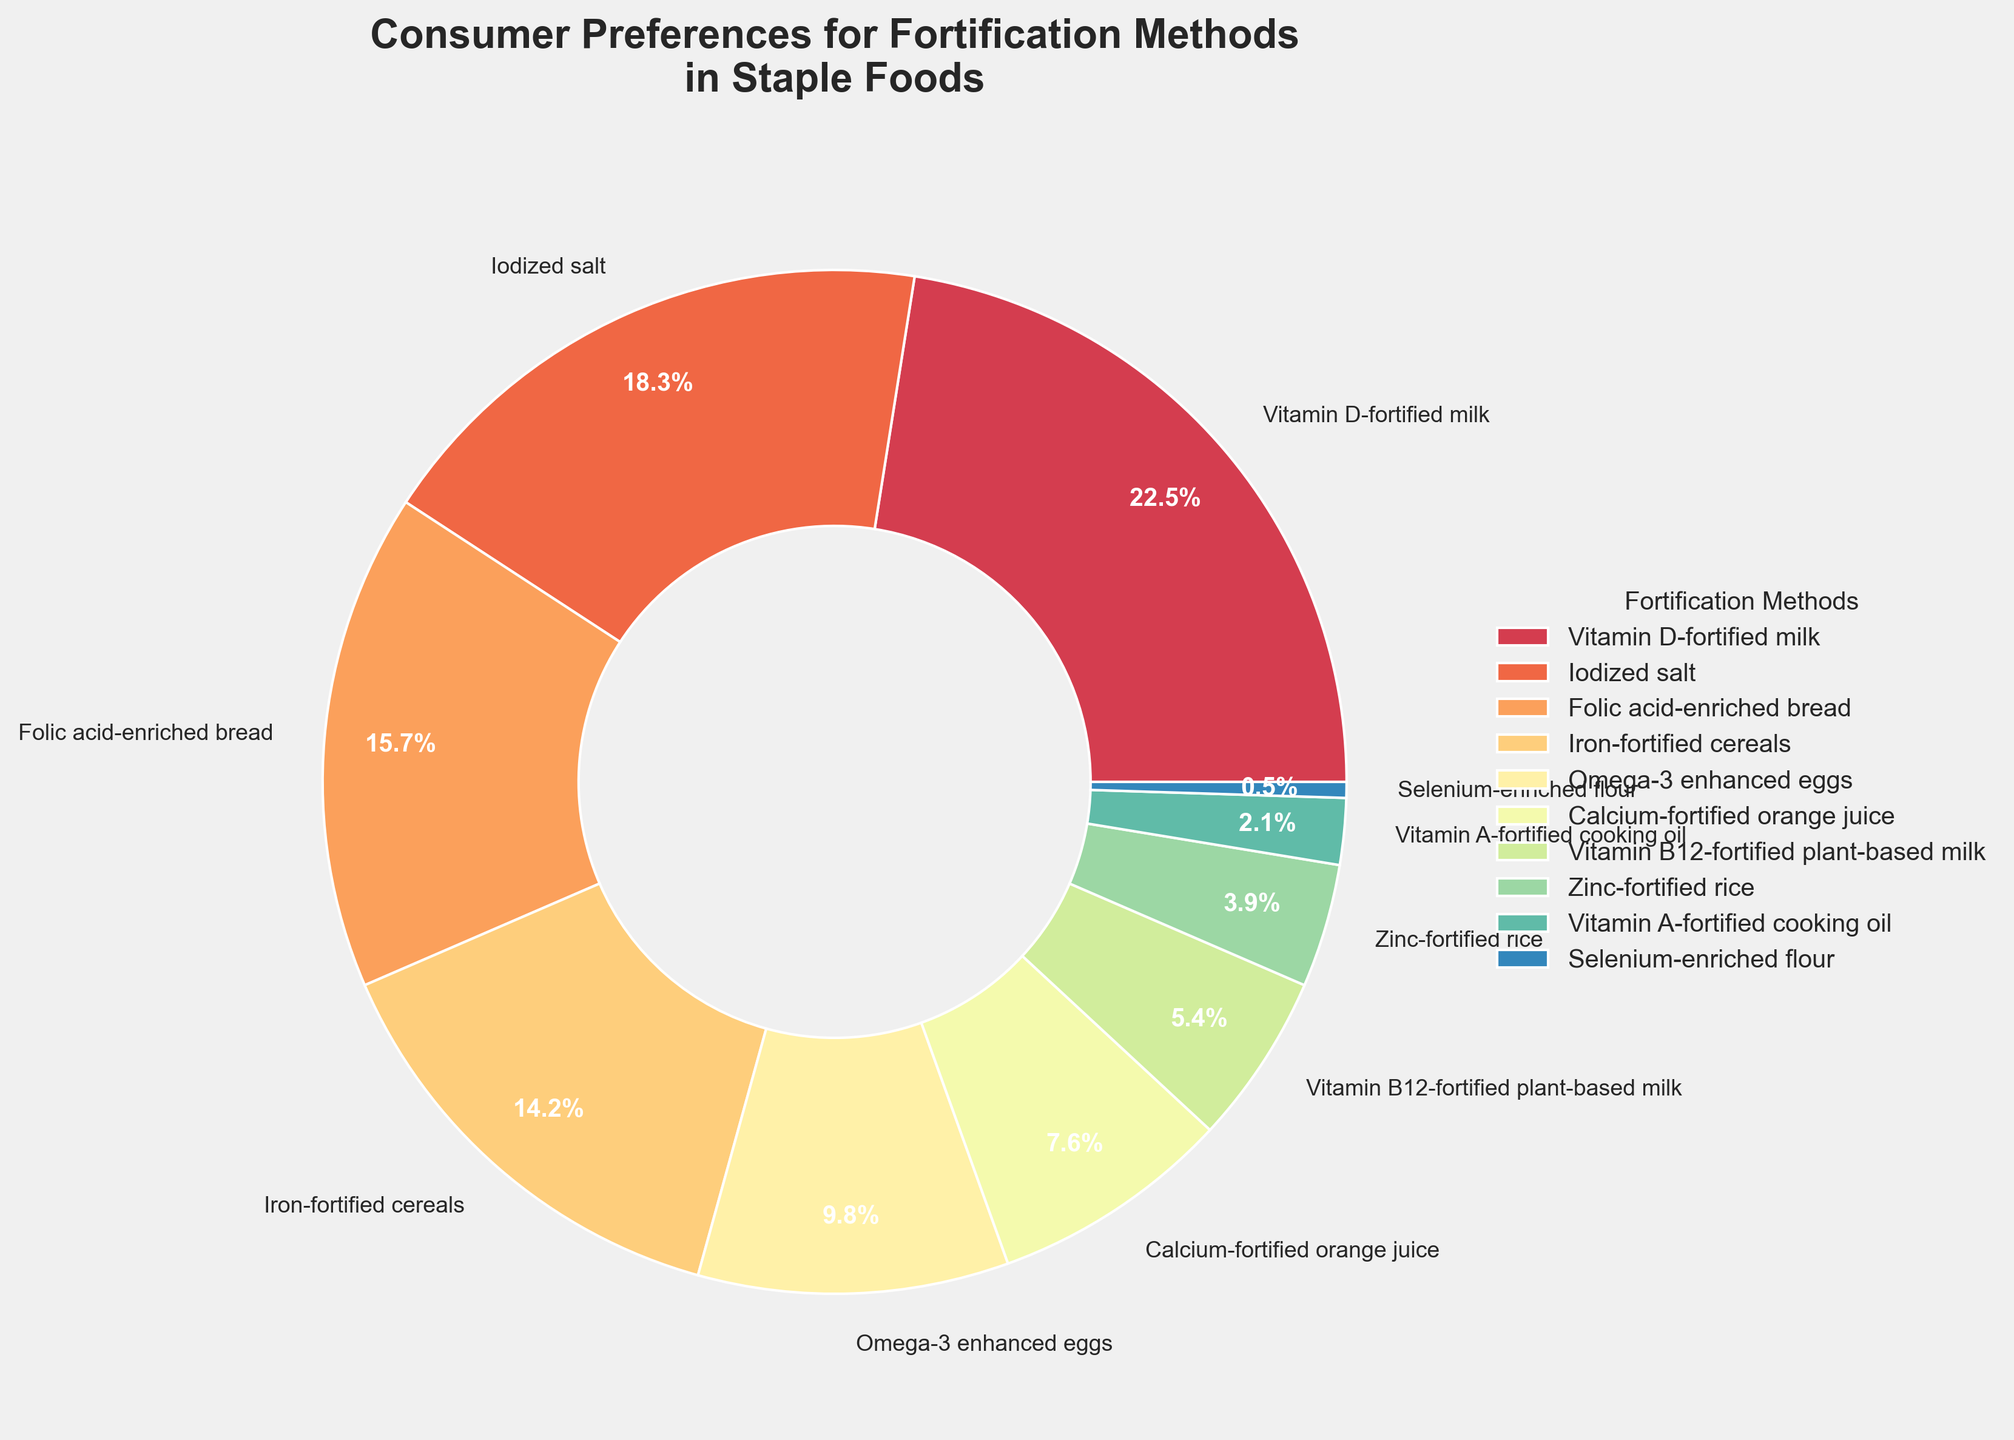What is the most preferred fortification method among consumers? To determine the most preferred fortification method, look for the slice of the pie chart that has the highest percentage. The one labeled "Vitamin D-fortified milk" has the highest value of 22.5%.
Answer: Vitamin D-fortified milk How much more preference does Vitamin D-fortified milk have compared to Selenium-enriched flour? Subtract the preference percentage of Selenium-enriched flour (0.5%) from the preference percentage of Vitamin D-fortified milk (22.5%). This gives 22.5% - 0.5% = 22.0%.
Answer: 22.0% Which fortification methods have a preference percentage greater than 15%? Look at each slice of the pie chart and check for the fortification methods with values greater than 15%. "Vitamin D-fortified milk" (22.5%), "Iodized salt" (18.3%), and "Folic acid-enriched bread" (15.7%) meet this criterion.
Answer: Vitamin D-fortified milk, Iodized salt, Folic acid-enriched bread What fortification method shows nearly half the consumer preference of Iodized salt? Consumer preference for Iodized salt is 18.3%. Half of this value is 9.15%. By inspecting the pie chart, the closest percentage to 9.15% is "Omega-3 enhanced eggs" with a preference of 9.8%.
Answer: Omega-3 enhanced eggs What is the combined preference percentage for Iron-fortified cereals and Omega-3 enhanced eggs? Add the preference percentages of Iron-fortified cereals (14.2%) and Omega-3 enhanced eggs (9.8%). This gives 14.2% + 9.8% = 24.0%.
Answer: 24.0% Among the fortification methods shown, which has the smallest consumer preference? Look for the smallest slice of the pie chart. The one labeled "Selenium-enriched flour" with a preference percentage of 0.5% is the smallest.
Answer: Selenium-enriched flour By how much does consumer preference for Calcium-fortified orange juice exceed that of Zinc-fortified rice? Subtract the preference percentage of Zinc-fortified rice (3.9%) from that of Calcium-fortified orange juice (7.6%). This gives 7.6% - 3.9% = 3.7%.
Answer: 3.7% What is the total preference percentage for all fortification methods below 10%? Add the percentages of fortification methods with consumer preference below 10%: Omega-3 enhanced eggs (9.8%), Calcium-fortified orange juice (7.6%), Vitamin B12-fortified plant-based milk (5.4%), Zinc-fortified rice (3.9%), Vitamin A-fortified cooking oil (2.1%), and Selenium-enriched flour (0.5%). This gives 9.8% + 7.6% + 5.4% + 3.9% + 2.1% + 0.5% = 29.3%.
Answer: 29.3% Which fortification method has the second-lowest consumer preference, and what is its percentage? Identify the fortification method with the second-smallest slice in the pie chart. "Vitamin A-fortified cooking oil" has the second-lowest preference percentage at 2.1%.
Answer: Vitamin A-fortified cooking oil, 2.1% Are preferences for Folic acid-enriched bread higher or lower than those for Iron-fortified cereals? Compare the preference percentages of Folic acid-enriched bread (15.7%) and Iron-fortified cereals (14.2%). Folic acid-enriched bread has a higher preference.
Answer: Higher 